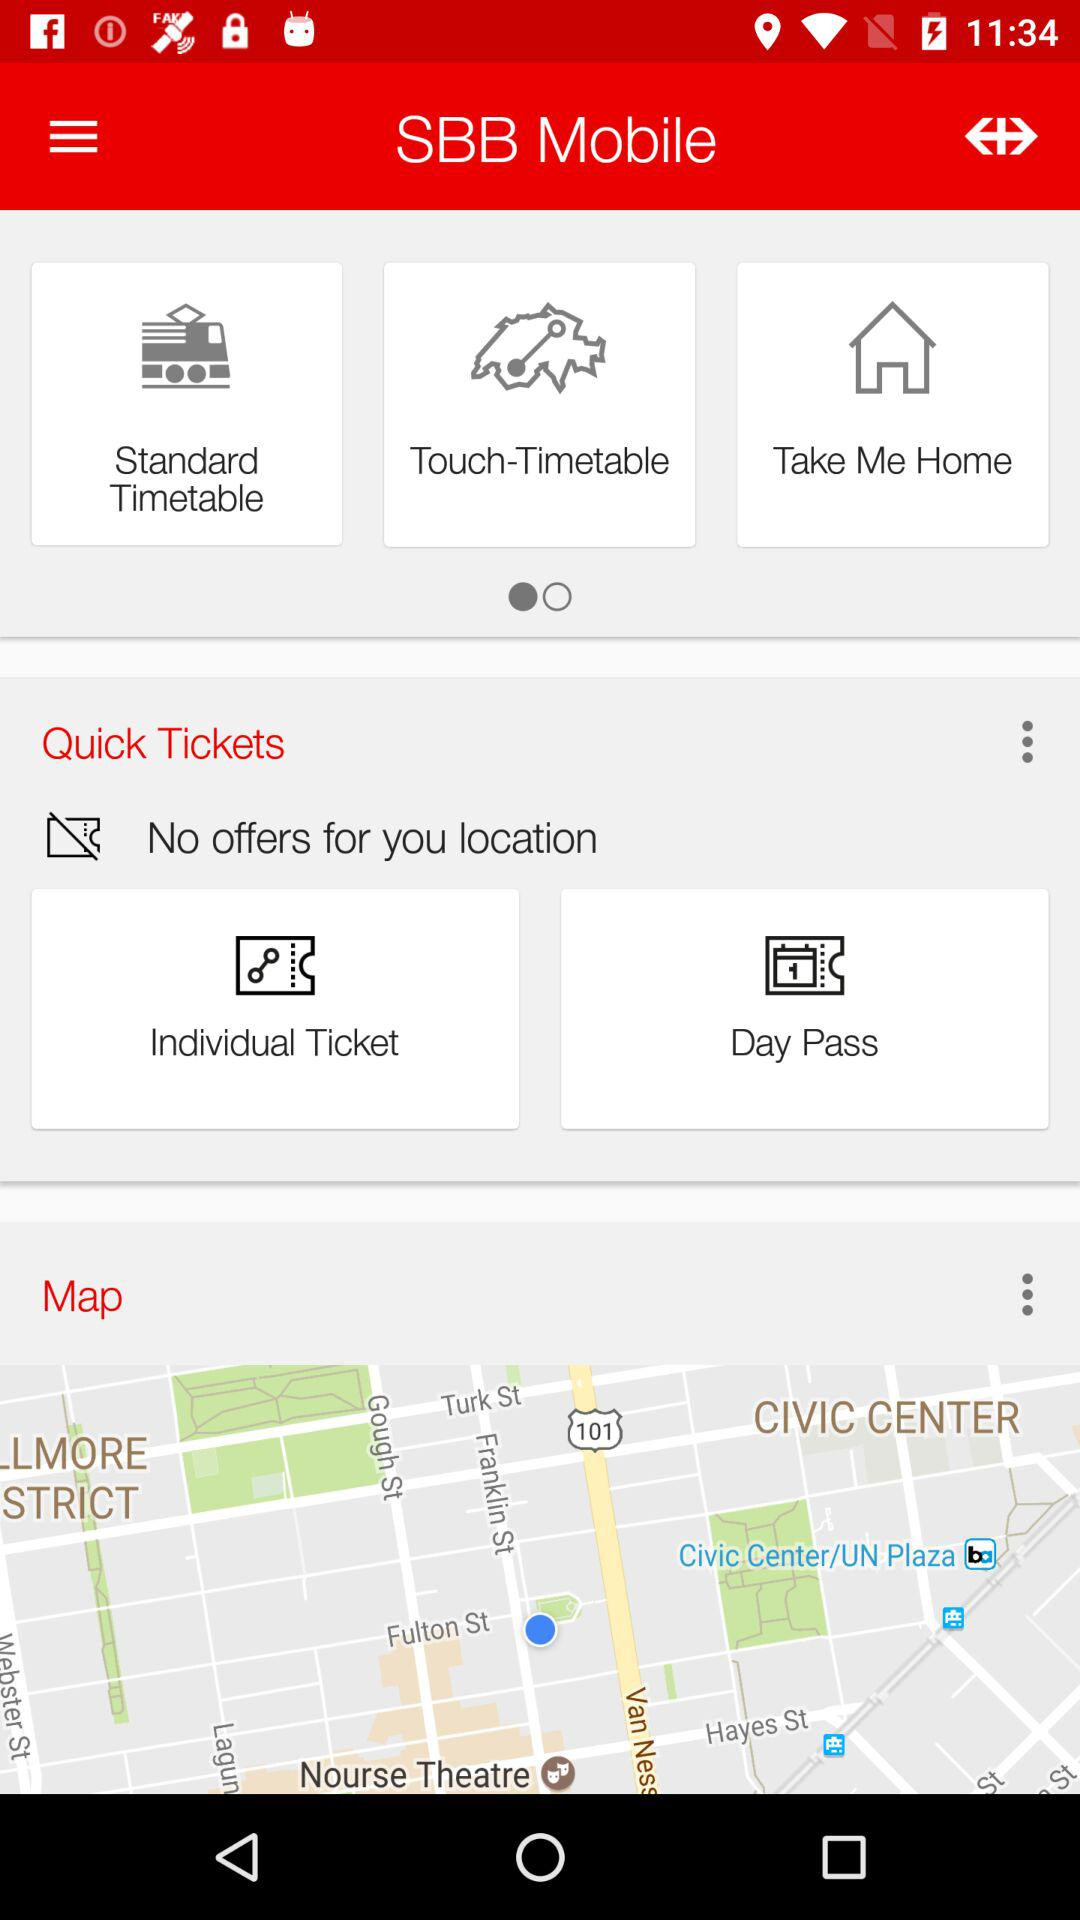Are there any offers available at your location? There is no offer available. 